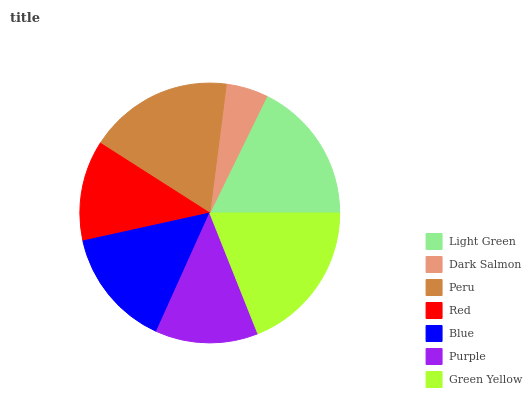Is Dark Salmon the minimum?
Answer yes or no. Yes. Is Green Yellow the maximum?
Answer yes or no. Yes. Is Peru the minimum?
Answer yes or no. No. Is Peru the maximum?
Answer yes or no. No. Is Peru greater than Dark Salmon?
Answer yes or no. Yes. Is Dark Salmon less than Peru?
Answer yes or no. Yes. Is Dark Salmon greater than Peru?
Answer yes or no. No. Is Peru less than Dark Salmon?
Answer yes or no. No. Is Blue the high median?
Answer yes or no. Yes. Is Blue the low median?
Answer yes or no. Yes. Is Red the high median?
Answer yes or no. No. Is Purple the low median?
Answer yes or no. No. 